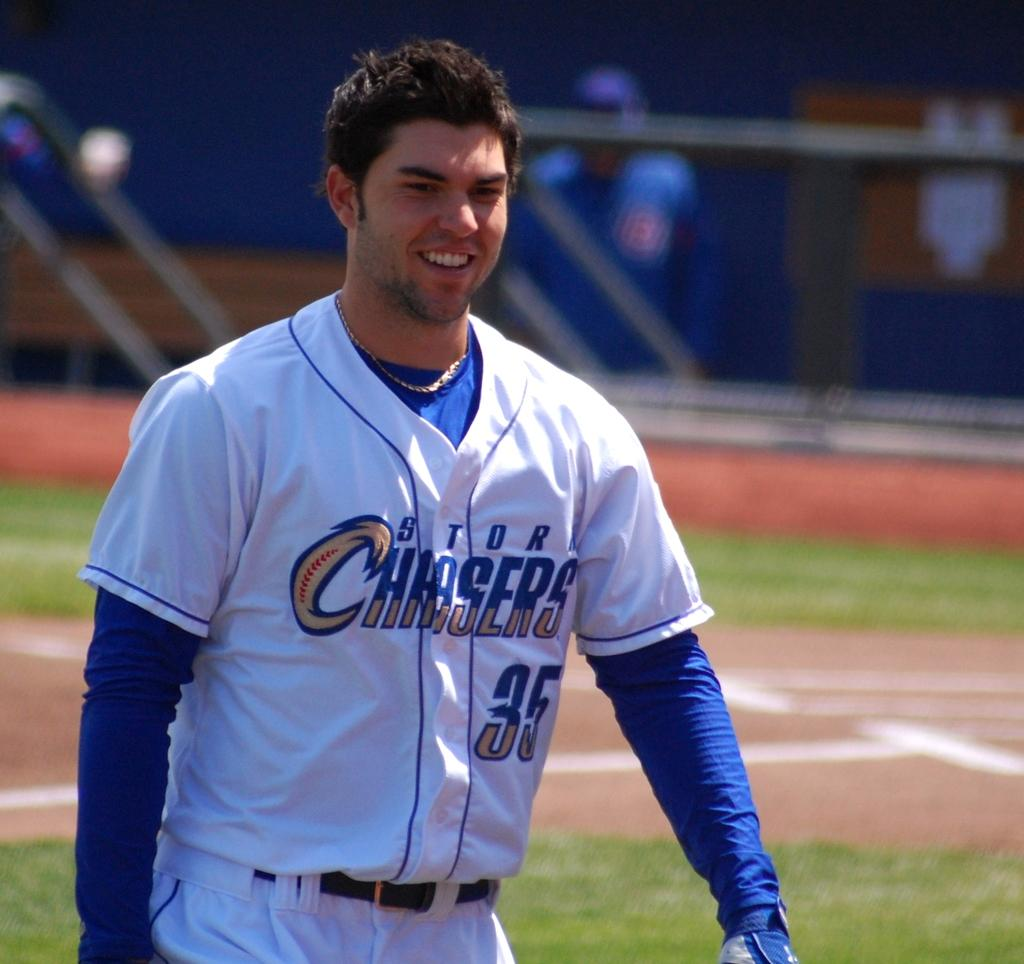<image>
Write a terse but informative summary of the picture. A baseball player with white and blue uniform that says Storm Chasers. 